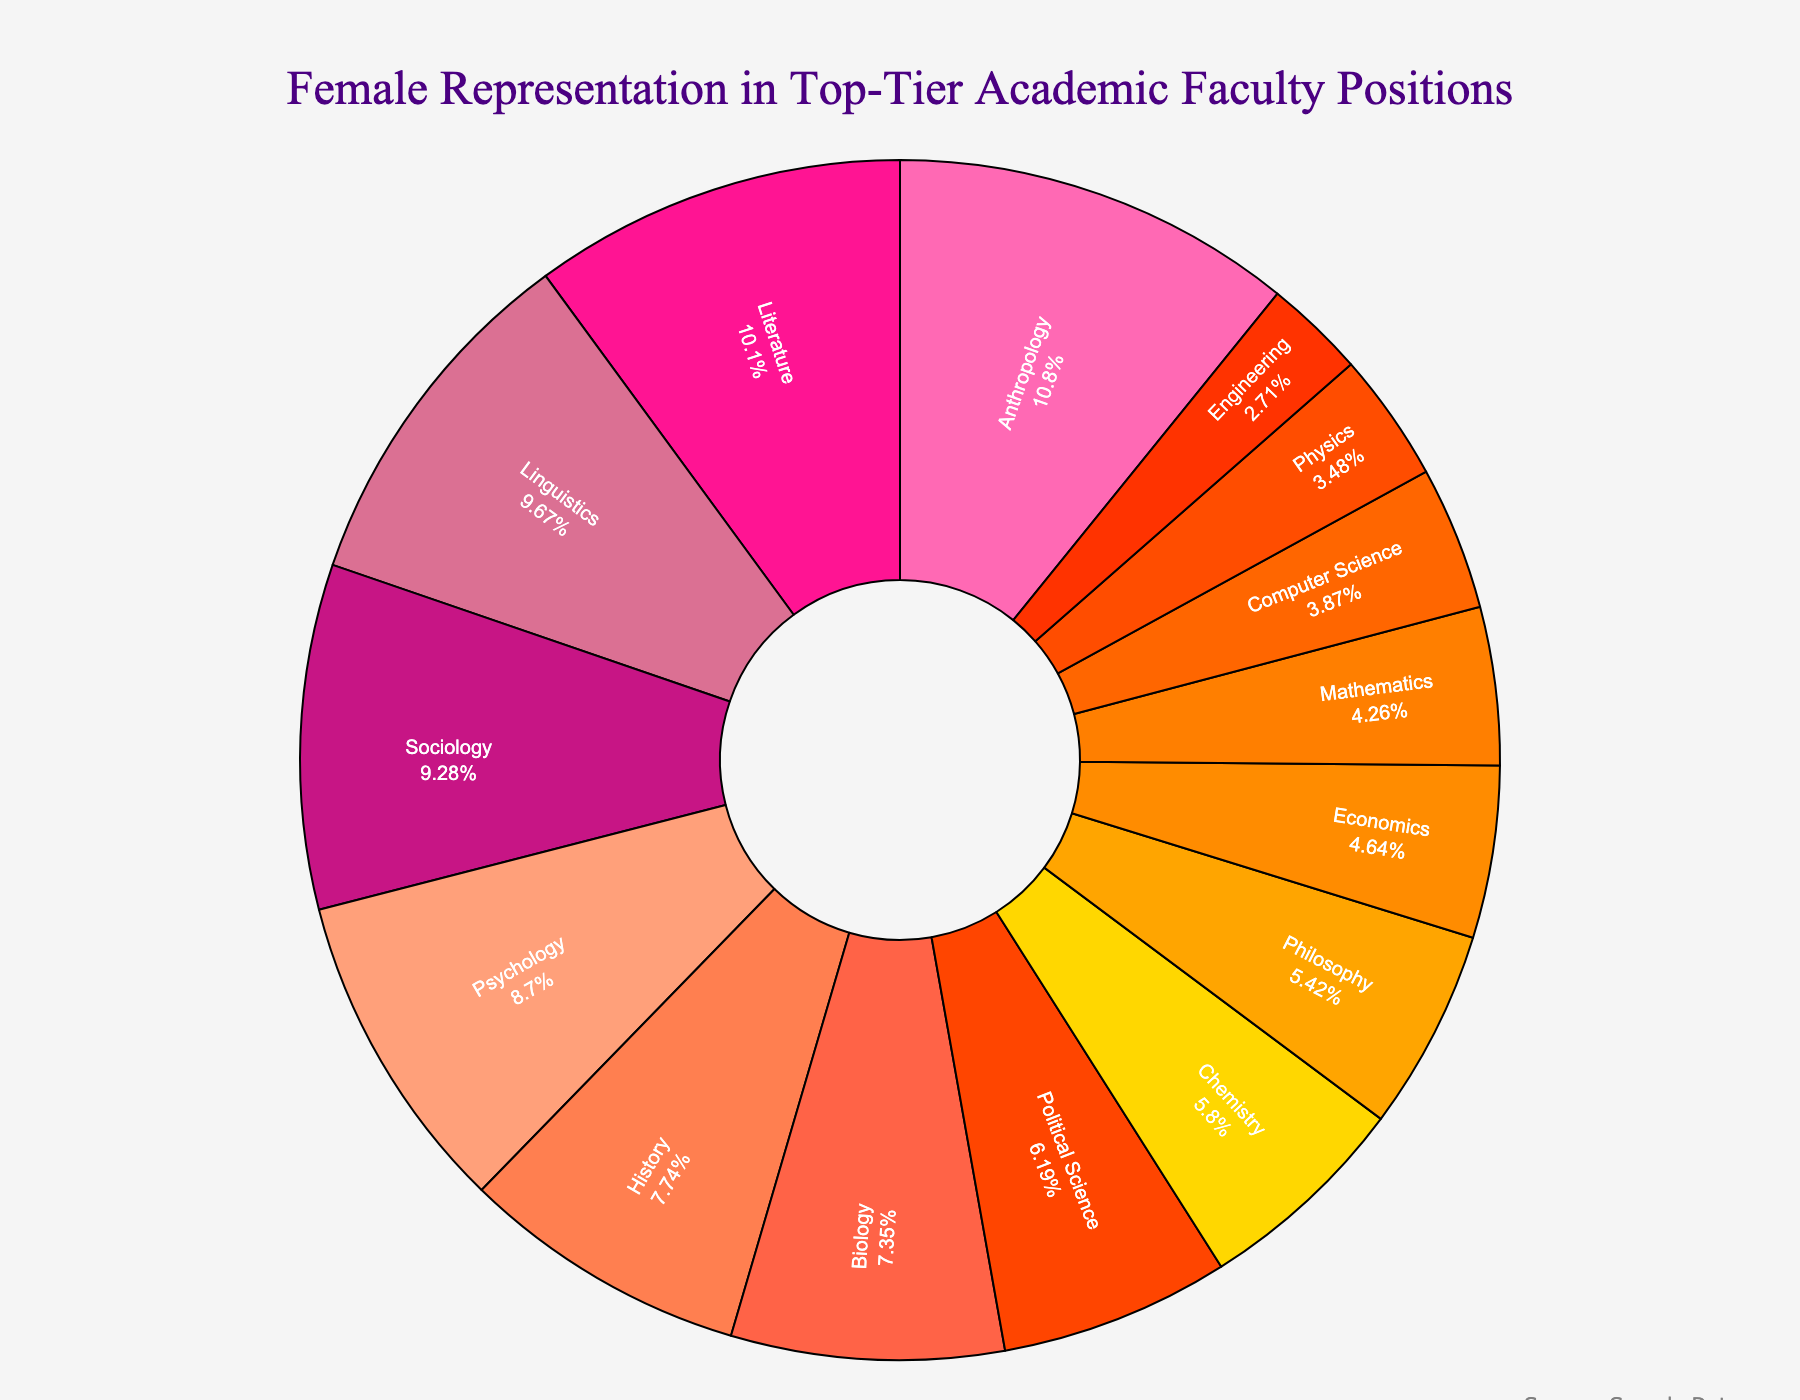What's the highest percentage of female representation by discipline? Identify the discipline with the largest segment and its associated percentage value. The largest segment represents Anthropology, having a slice with the value 56%.
Answer: 56% Which disciplines have a female representation percentage in the 30's range? Scan the chart for segments with percentages between 30% and 40%. The found segments correspond to Biology (38%), Chemistry (30%), and History (40%).
Answer: Biology, Chemistry, History How much more female representation is there in Psychology compared to Mathematics? Identify and compare the percentages of Psychology (45%) and Mathematics (22%). Subtract the smaller value from the larger one: 45% - 22% = 23%.
Answer: 23% What is the combined percentage of female representation in Sociology and Political Science? Identify the percentages for Sociology (48%) and Political Science (32%), then add them together: 48% + 32% = 80%.
Answer: 80% Which discipline has a smaller percentage of female representation, Physics or Computer Science? Compare the two percentages: Physics (18%) and Computer Science (20%). The smaller percentage is associated with Physics.
Answer: Physics List all disciplines with female representation greater than 50%. Identify the segments with percentages over 50%. This includes Literature (52%) and Anthropology (56%).
Answer: Literature, Anthropology What is the average percentage of female representation across Engineering, Economics, and Philosophy? Identify the percentages of Engineering (14%), Economics (24%), and Philosophy (28%), then calculate the average: (14% + 24% + 28%) / 3 = 22%.
Answer: 22% Which discipline has a higher female representation, Biology or Chemistry? Compare the two percentages: Biology (38%) and Chemistry (30%). The higher percentage is associated with Biology.
Answer: Biology 